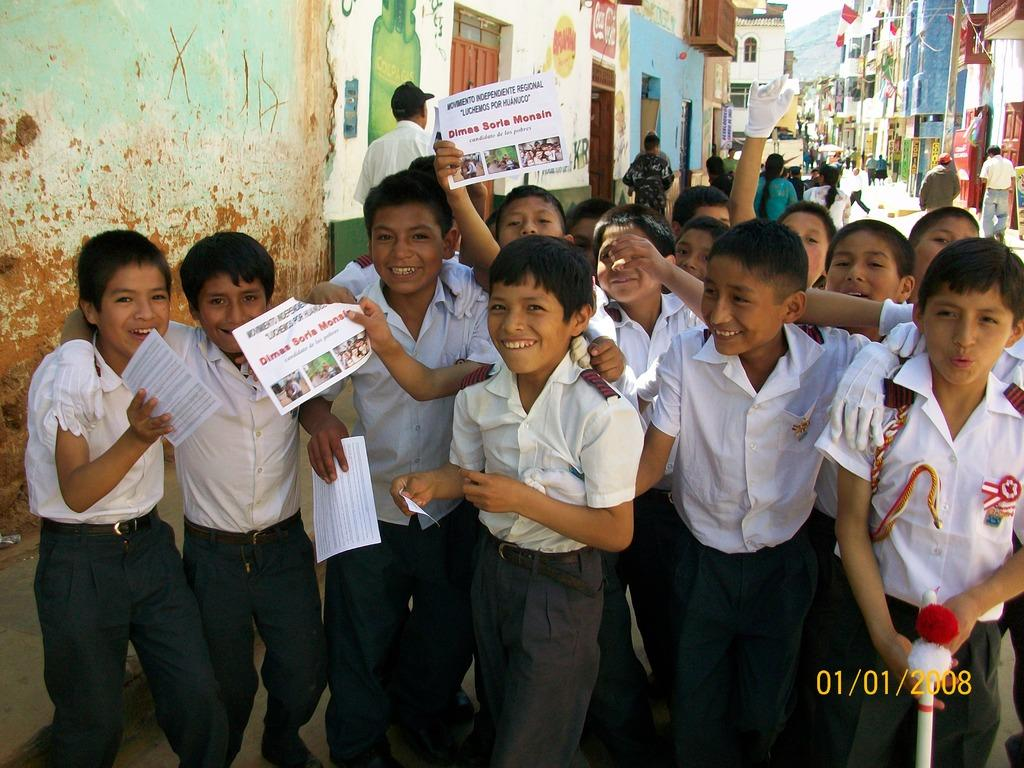What is the main subject of the image? The main subject of the image is a group of children. What are the children holding in the image? The children are holding papers in the image. What can be seen in the background of the image? In the background of the image, there is a person walking, buildings with windows, and the sky. What type of shirt is the son wearing in the image? There is no son present in the image, so it is not possible to determine what type of shirt they might be wearing. 